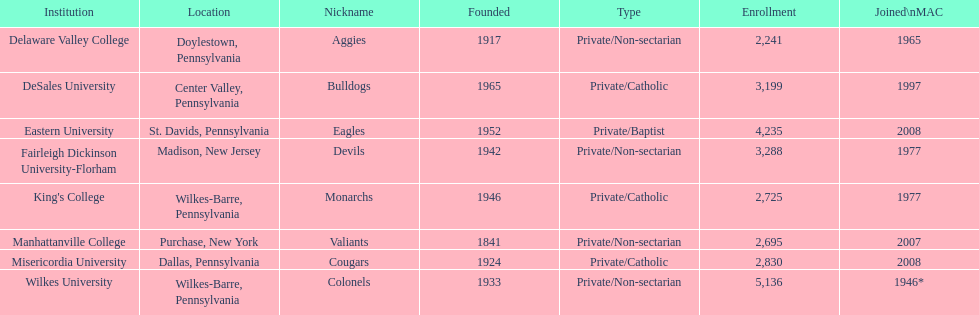What is the number of registrations in private/catholic institutions? 8,754. 